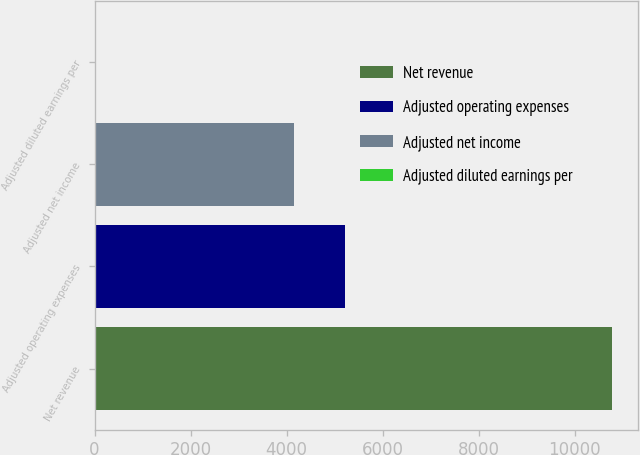Convert chart. <chart><loc_0><loc_0><loc_500><loc_500><bar_chart><fcel>Net revenue<fcel>Adjusted operating expenses<fcel>Adjusted net income<fcel>Adjusted diluted earnings per<nl><fcel>10776<fcel>5221.22<fcel>4144<fcel>3.77<nl></chart> 